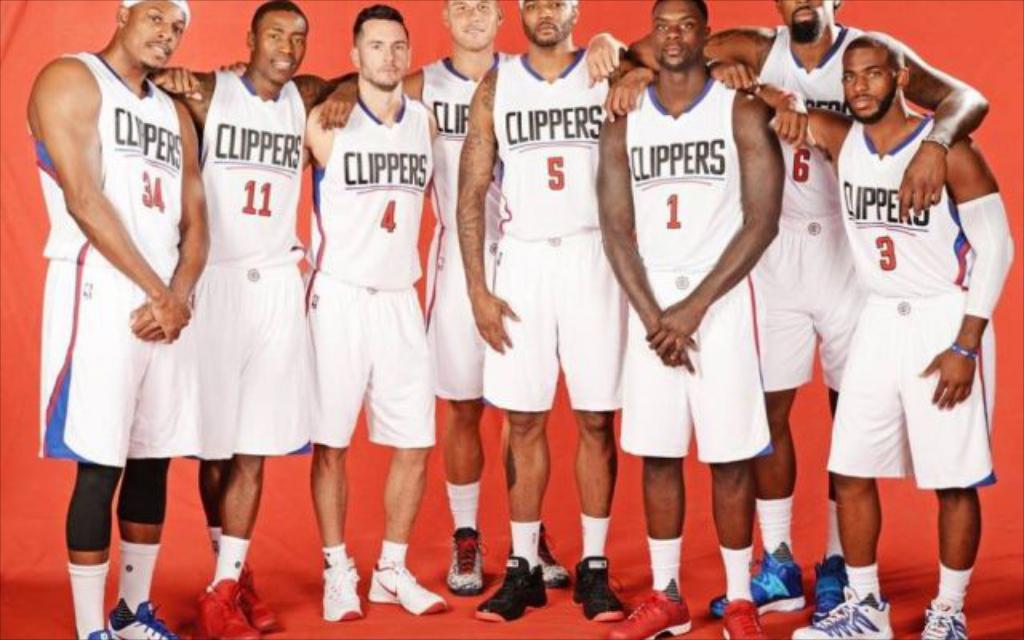<image>
Offer a succinct explanation of the picture presented. An image of the Clippers basketball team posing for a picture. 